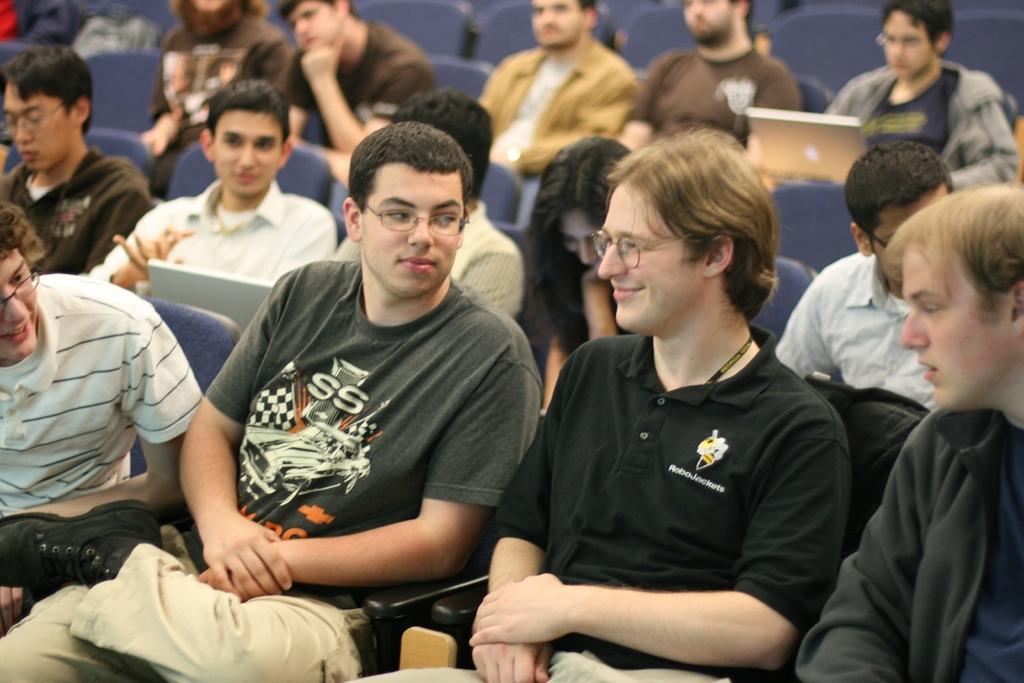In one or two sentences, can you explain what this image depicts? In this image we can see people sitting on the chairs and there are laptops. 